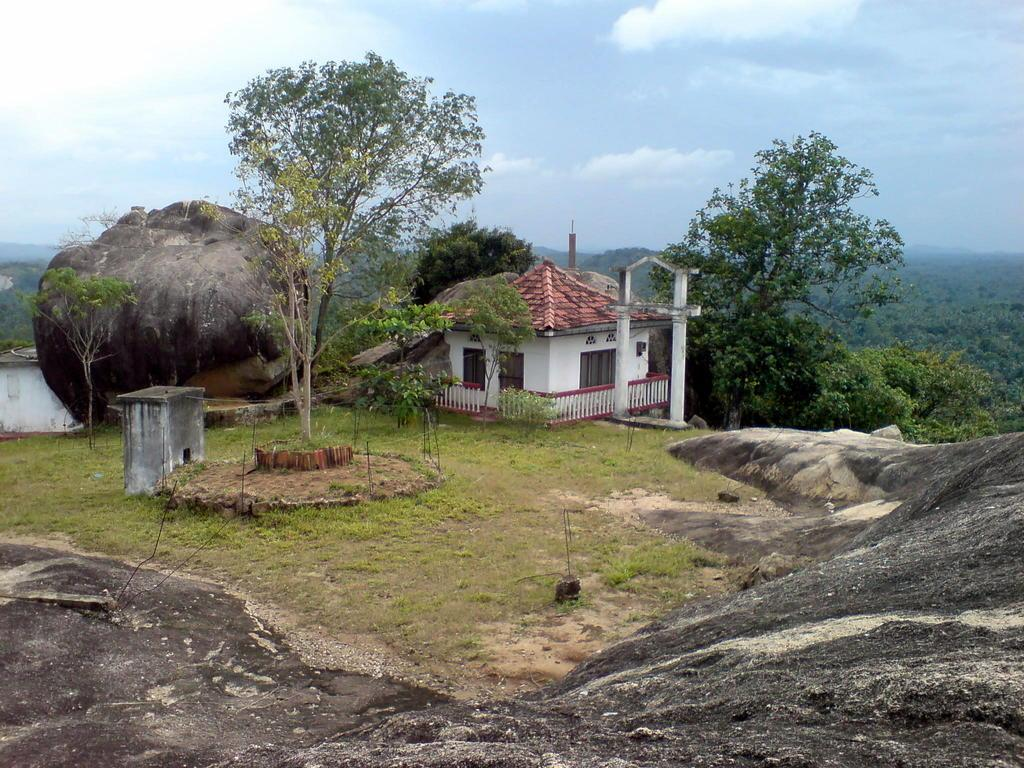What is the main structure in the middle of the image? There is a home in the middle of the image. What can be seen surrounding the home? Huge stones are surrounding the home. What type of landscaping is in front of the home? There is a garden in front of the home. What is visible behind the home? Trees are present in the back of the home. What is visible at the top of the image? The sky is visible in the image. What can be seen in the sky? Clouds are present in the sky. Can you tell me how many pears are hanging from the trees in the image? There are no pears visible in the image; only trees are present. What type of dog can be seen playing in the garden in the image? There is no dog present in the image; only a garden is visible in front of the home. 